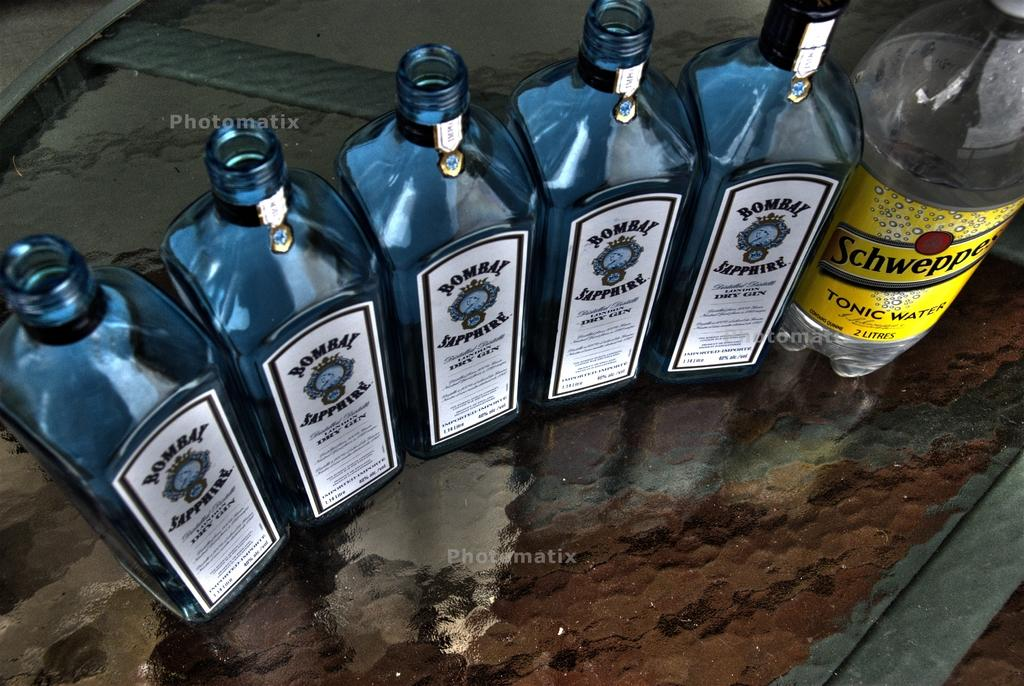<image>
Describe the image concisely. 5 bottles of Bombay gin and 1 bottle of Tonic Water. 